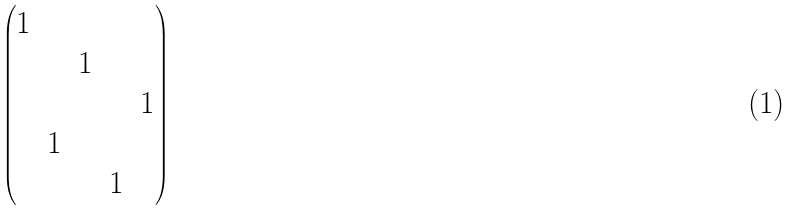Convert formula to latex. <formula><loc_0><loc_0><loc_500><loc_500>\begin{pmatrix} 1 & & & & \\ & & 1 & & \\ & & & & 1 \\ & 1 & & & \\ & & & 1 & \end{pmatrix}</formula> 